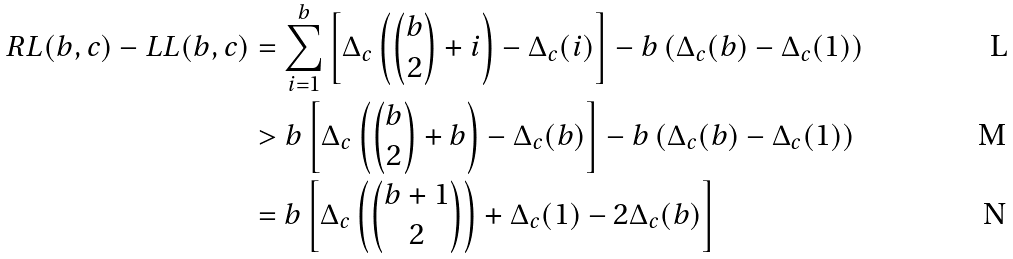Convert formula to latex. <formula><loc_0><loc_0><loc_500><loc_500>R L ( b , c ) - L L ( b , c ) & = \sum _ { i = 1 } ^ { b } \left [ \Delta _ { c } \left ( \binom { b } { 2 } + i \right ) - \Delta _ { c } ( i ) \right ] - b \left ( \Delta _ { c } ( b ) - \Delta _ { c } ( 1 ) \right ) \\ & > b \left [ \Delta _ { c } \left ( \binom { b } { 2 } + b \right ) - \Delta _ { c } ( b ) \right ] - b \left ( \Delta _ { c } ( b ) - \Delta _ { c } ( 1 ) \right ) \\ & = b \left [ \Delta _ { c } \left ( \binom { b + 1 } { 2 } \right ) + \Delta _ { c } ( 1 ) - 2 \Delta _ { c } ( b ) \right ]</formula> 